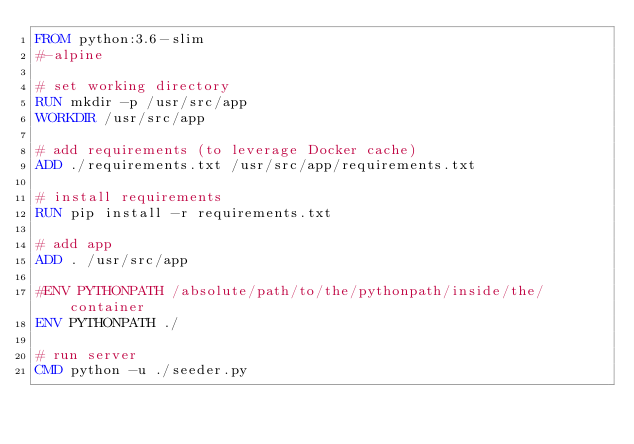Convert code to text. <code><loc_0><loc_0><loc_500><loc_500><_Dockerfile_>FROM python:3.6-slim
#-alpine

# set working directory
RUN mkdir -p /usr/src/app
WORKDIR /usr/src/app

# add requirements (to leverage Docker cache)
ADD ./requirements.txt /usr/src/app/requirements.txt

# install requirements
RUN pip install -r requirements.txt

# add app
ADD . /usr/src/app

#ENV PYTHONPATH /absolute/path/to/the/pythonpath/inside/the/container
ENV PYTHONPATH ./

# run server
CMD python -u ./seeder.py</code> 